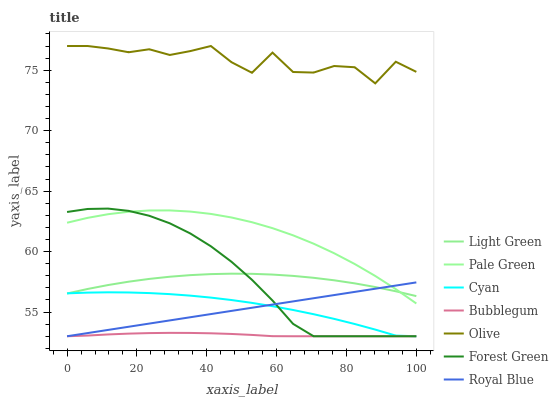Does Royal Blue have the minimum area under the curve?
Answer yes or no. No. Does Royal Blue have the maximum area under the curve?
Answer yes or no. No. Is Forest Green the smoothest?
Answer yes or no. No. Is Forest Green the roughest?
Answer yes or no. No. Does Pale Green have the lowest value?
Answer yes or no. No. Does Royal Blue have the highest value?
Answer yes or no. No. Is Cyan less than Olive?
Answer yes or no. Yes. Is Olive greater than Cyan?
Answer yes or no. Yes. Does Cyan intersect Olive?
Answer yes or no. No. 